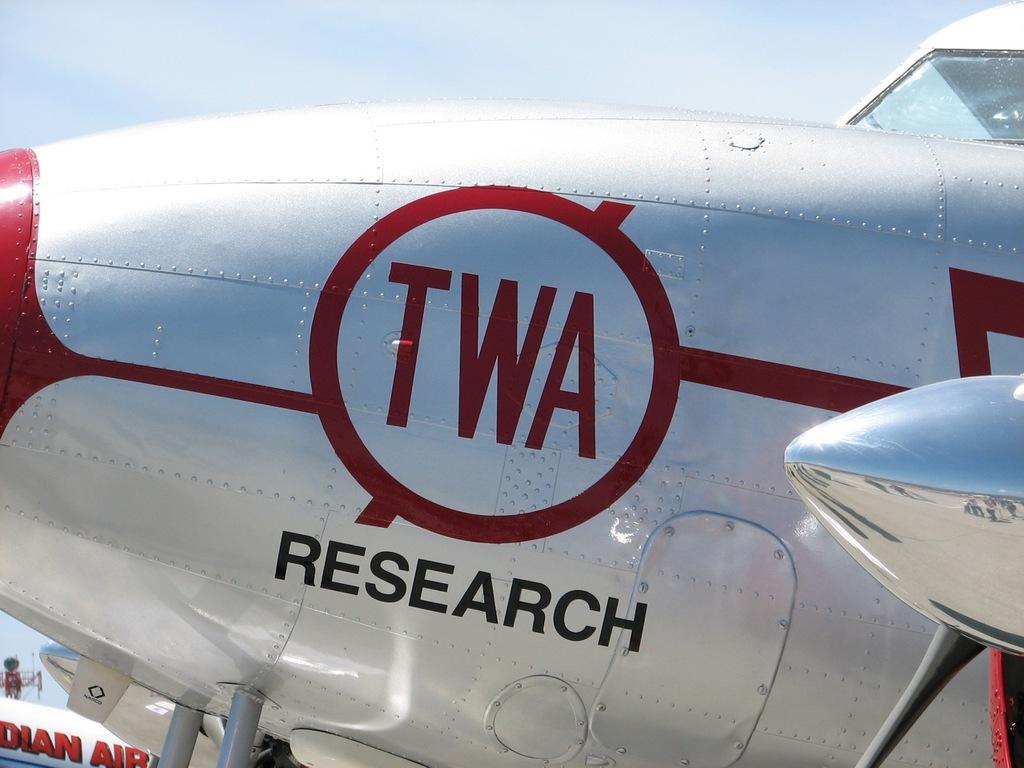What is the main subject of the image? The main subject of the image is an aircraft. What colors can be seen on the aircraft? The aircraft is white, red, and black in color. What can be seen in the background of the image? There are other aircrafts and a tower in the background of the image. What is visible in the sky in the image? The sky is visible in the background of the image. Can you describe the taste of the bird in the image? There is no bird present in the image, so it is not possible to describe its taste. 